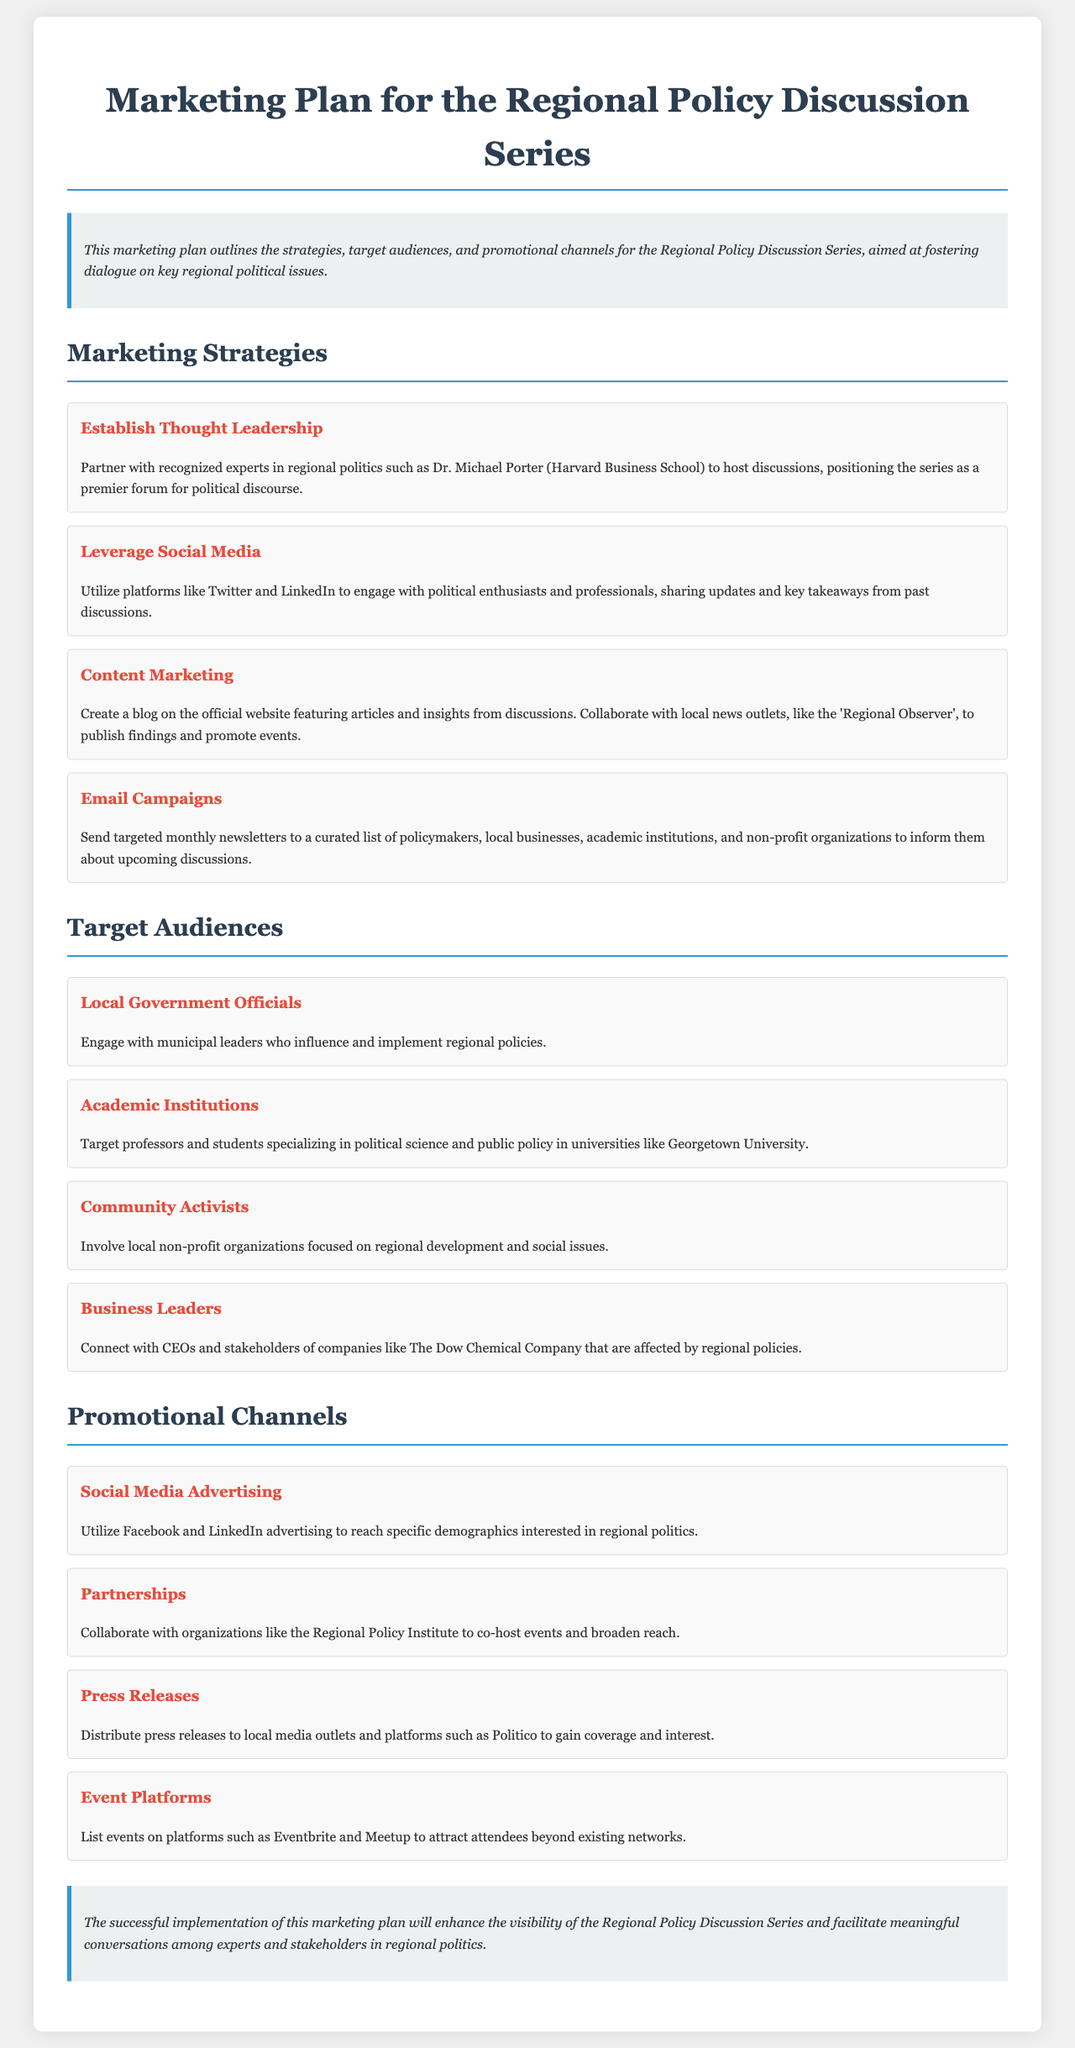What is the purpose of the marketing plan? The marketing plan outlines the strategies, target audiences, and promotional channels for the Regional Policy Discussion Series.
Answer: Strategies, target audiences, and promotional channels Who is a partner mentioned in the thought leadership strategy? Dr. Michael Porter is cited as a recognized expert to partner with for discussions.
Answer: Dr. Michael Porter How often should newsletters be sent out? The document mentions sending targeted monthly newsletters to the audience.
Answer: Monthly Which platform is recommended for social media advertising? The marketing plan suggests using Facebook and LinkedIn for advertising.
Answer: Facebook and LinkedIn What type of individuals does the target audience include that are related to academic institutions? The target audience specifies professors and students in political science and public policy.
Answer: Professors and students Which organization is suggested for partnerships? The marketing plan mentions the Regional Policy Institute for collaboration.
Answer: Regional Policy Institute What type of marketing strategy is mentioned alongside email campaigns? The marketing strategies include content marketing as one of the approaches.
Answer: Content Marketing What is one of the promotional channels for gathering more attendees? The document suggests listing events on Eventbrite to attract attendees.
Answer: Eventbrite 